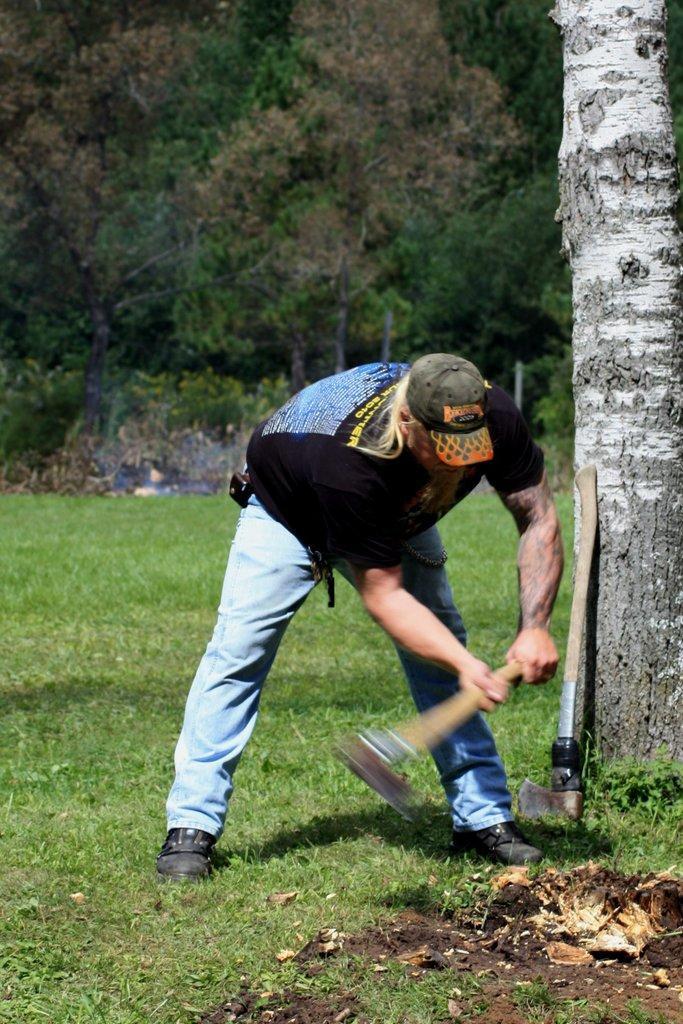Describe this image in one or two sentences. In this image we can see a person holding an axe and there is a another axe on the ground, there are poles, trees and grass. 